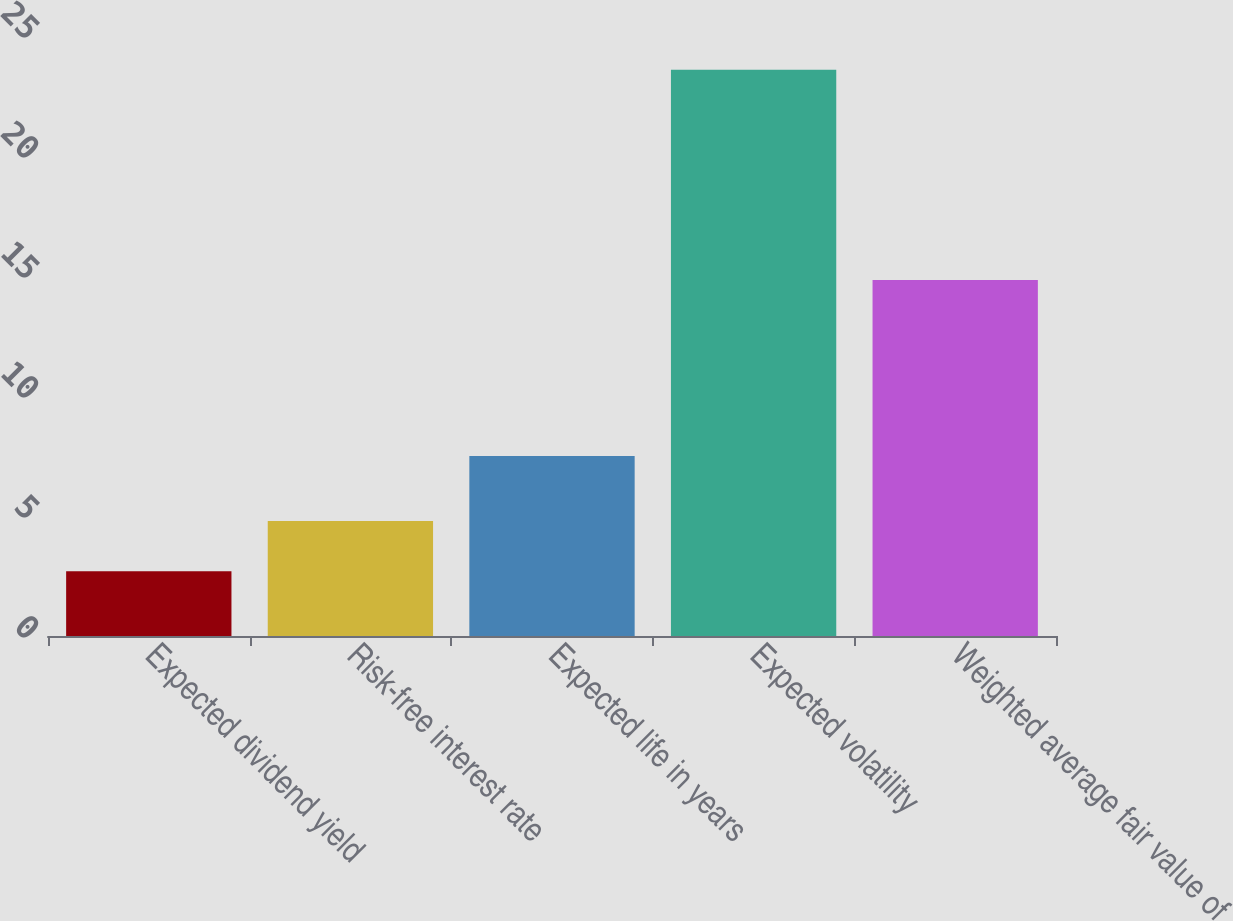Convert chart to OTSL. <chart><loc_0><loc_0><loc_500><loc_500><bar_chart><fcel>Expected dividend yield<fcel>Risk-free interest rate<fcel>Expected life in years<fcel>Expected volatility<fcel>Weighted average fair value of<nl><fcel>2.7<fcel>4.79<fcel>7.5<fcel>23.59<fcel>14.83<nl></chart> 